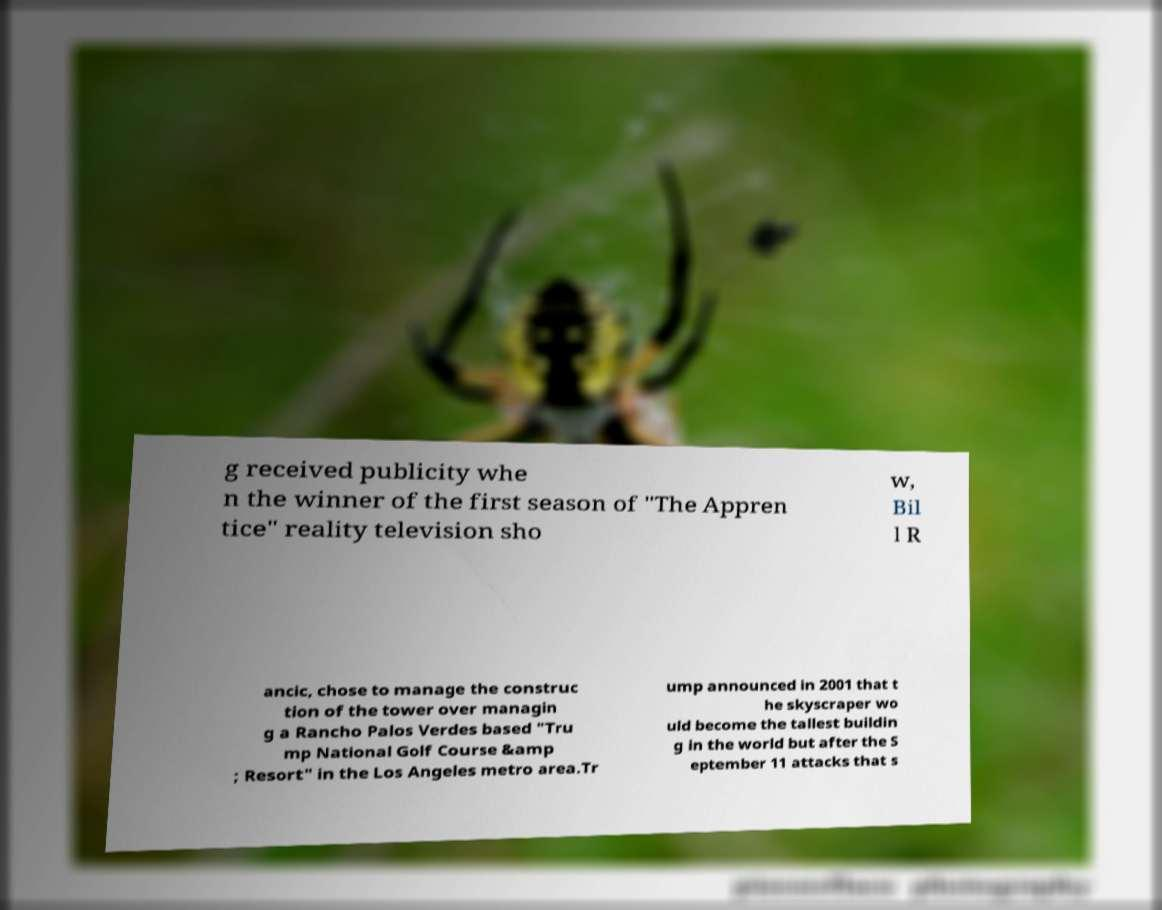Could you extract and type out the text from this image? g received publicity whe n the winner of the first season of "The Appren tice" reality television sho w, Bil l R ancic, chose to manage the construc tion of the tower over managin g a Rancho Palos Verdes based "Tru mp National Golf Course &amp ; Resort" in the Los Angeles metro area.Tr ump announced in 2001 that t he skyscraper wo uld become the tallest buildin g in the world but after the S eptember 11 attacks that s 